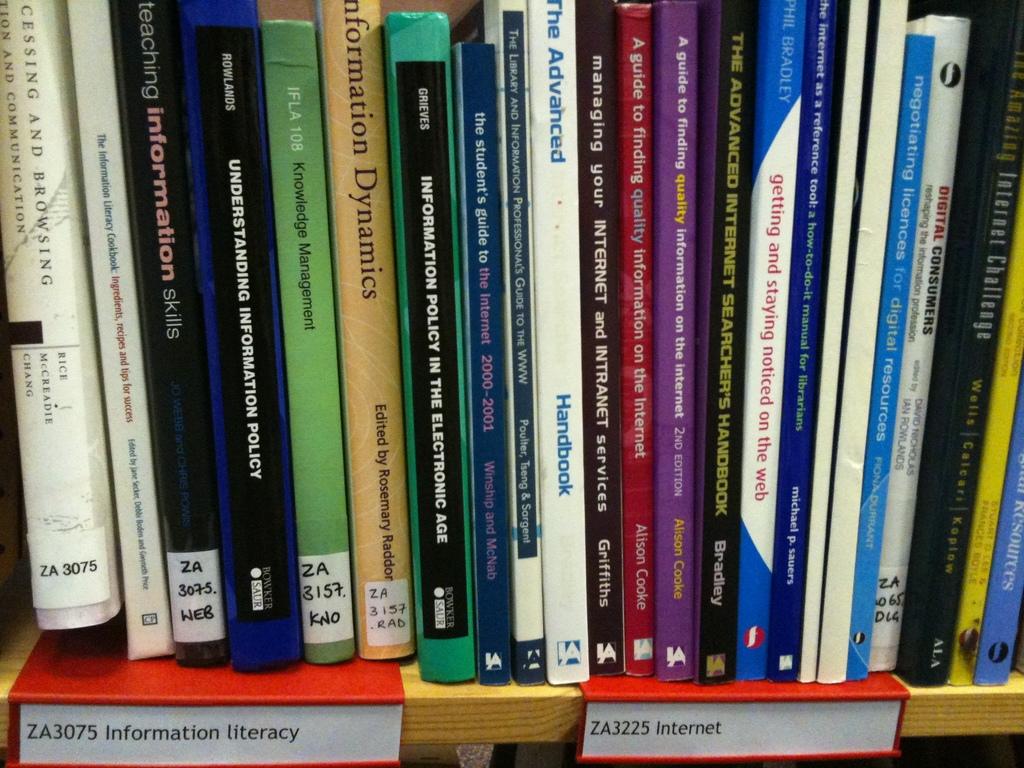What type of books are on the shelf?
Keep it short and to the point. Information literacy and internet. 